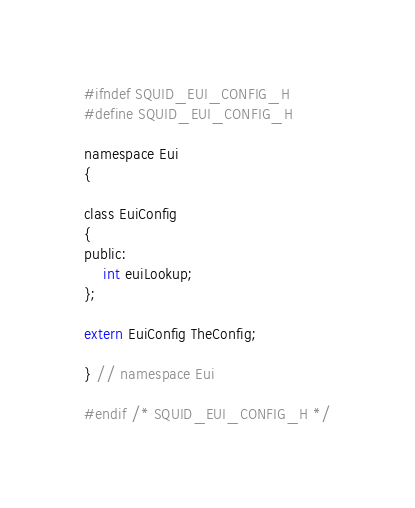Convert code to text. <code><loc_0><loc_0><loc_500><loc_500><_C_>#ifndef SQUID_EUI_CONFIG_H
#define SQUID_EUI_CONFIG_H

namespace Eui
{

class EuiConfig
{
public:
    int euiLookup;
};

extern EuiConfig TheConfig;

} // namespace Eui

#endif /* SQUID_EUI_CONFIG_H */
</code> 